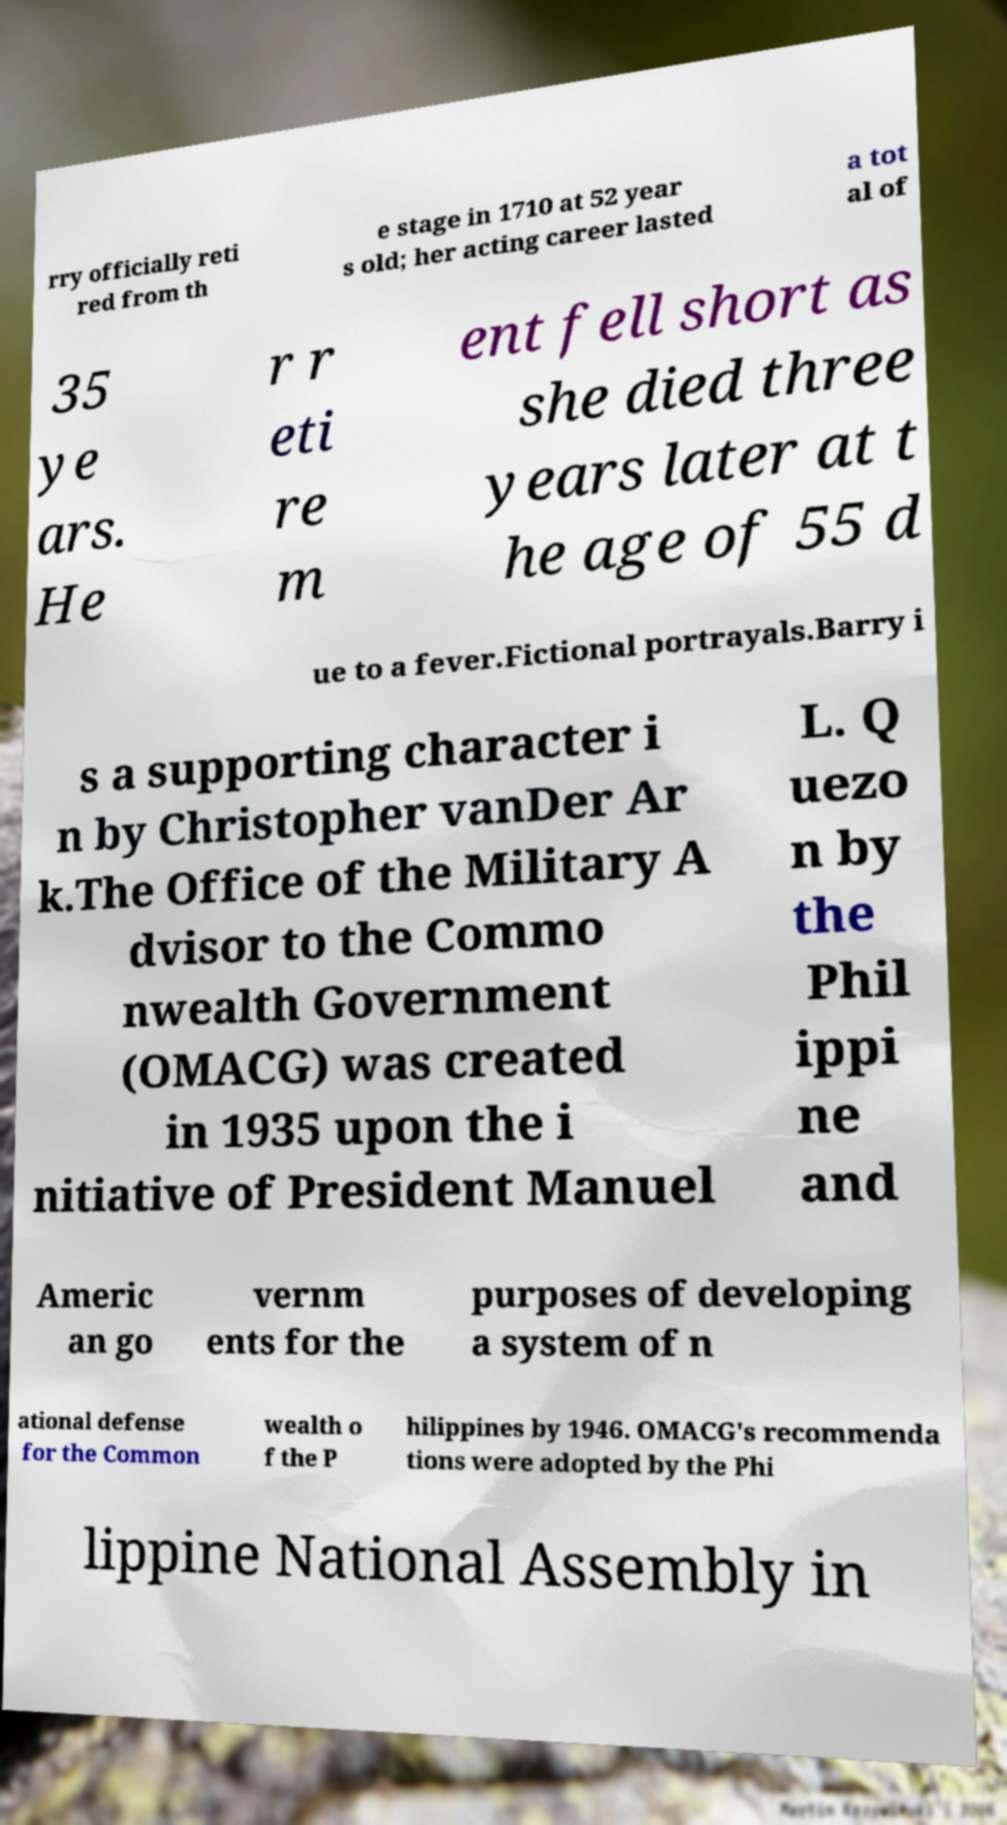Please identify and transcribe the text found in this image. rry officially reti red from th e stage in 1710 at 52 year s old; her acting career lasted a tot al of 35 ye ars. He r r eti re m ent fell short as she died three years later at t he age of 55 d ue to a fever.Fictional portrayals.Barry i s a supporting character i n by Christopher vanDer Ar k.The Office of the Military A dvisor to the Commo nwealth Government (OMACG) was created in 1935 upon the i nitiative of President Manuel L. Q uezo n by the Phil ippi ne and Americ an go vernm ents for the purposes of developing a system of n ational defense for the Common wealth o f the P hilippines by 1946. OMACG's recommenda tions were adopted by the Phi lippine National Assembly in 